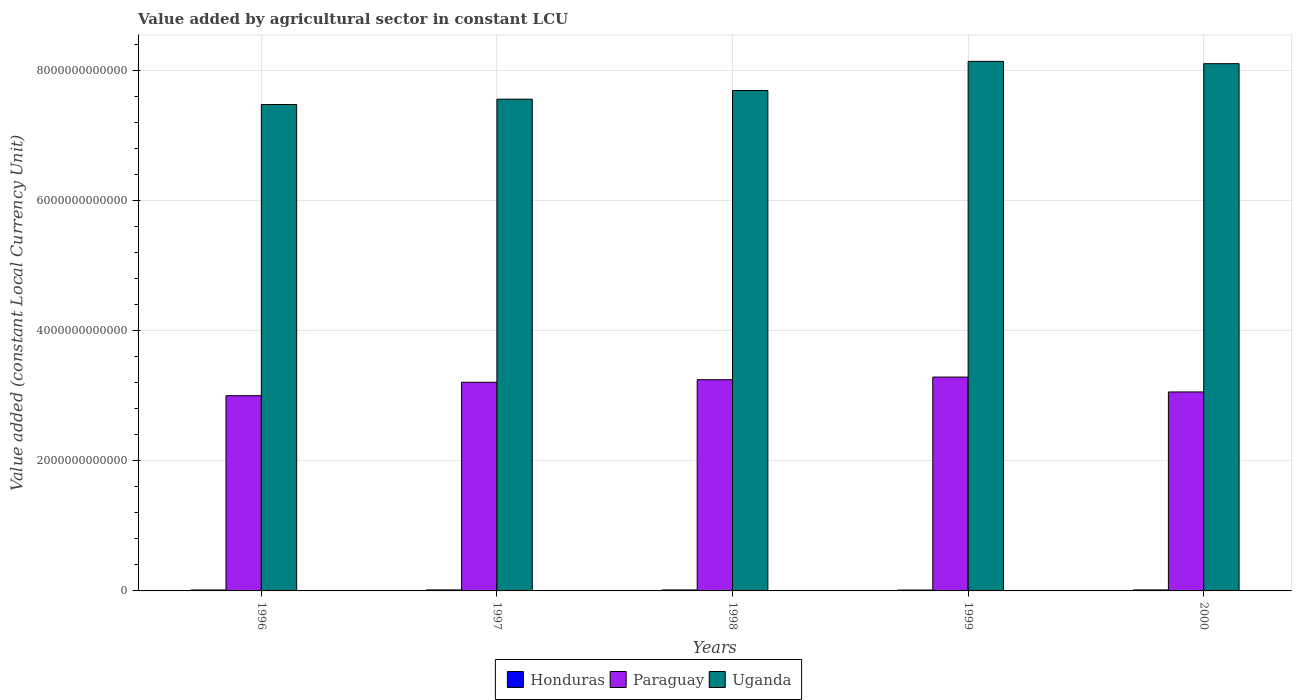How many groups of bars are there?
Ensure brevity in your answer.  5. Are the number of bars per tick equal to the number of legend labels?
Your answer should be compact. Yes. Are the number of bars on each tick of the X-axis equal?
Provide a succinct answer. Yes. How many bars are there on the 4th tick from the left?
Give a very brief answer. 3. How many bars are there on the 3rd tick from the right?
Ensure brevity in your answer.  3. What is the label of the 3rd group of bars from the left?
Your answer should be very brief. 1998. In how many cases, is the number of bars for a given year not equal to the number of legend labels?
Provide a short and direct response. 0. What is the value added by agricultural sector in Paraguay in 1998?
Your answer should be compact. 3.25e+12. Across all years, what is the maximum value added by agricultural sector in Paraguay?
Provide a succinct answer. 3.29e+12. Across all years, what is the minimum value added by agricultural sector in Uganda?
Give a very brief answer. 7.48e+12. What is the total value added by agricultural sector in Uganda in the graph?
Your answer should be very brief. 3.90e+13. What is the difference between the value added by agricultural sector in Paraguay in 1997 and that in 2000?
Your answer should be very brief. 1.49e+11. What is the difference between the value added by agricultural sector in Honduras in 1998 and the value added by agricultural sector in Uganda in 1996?
Give a very brief answer. -7.47e+12. What is the average value added by agricultural sector in Paraguay per year?
Offer a terse response. 3.16e+12. In the year 1997, what is the difference between the value added by agricultural sector in Paraguay and value added by agricultural sector in Honduras?
Provide a succinct answer. 3.19e+12. In how many years, is the value added by agricultural sector in Paraguay greater than 4000000000000 LCU?
Give a very brief answer. 0. What is the ratio of the value added by agricultural sector in Uganda in 1996 to that in 2000?
Ensure brevity in your answer.  0.92. What is the difference between the highest and the second highest value added by agricultural sector in Honduras?
Provide a succinct answer. 4.65e+07. What is the difference between the highest and the lowest value added by agricultural sector in Paraguay?
Give a very brief answer. 2.86e+11. In how many years, is the value added by agricultural sector in Uganda greater than the average value added by agricultural sector in Uganda taken over all years?
Your answer should be compact. 2. What does the 3rd bar from the left in 1999 represents?
Provide a short and direct response. Uganda. What does the 2nd bar from the right in 1998 represents?
Make the answer very short. Paraguay. Is it the case that in every year, the sum of the value added by agricultural sector in Honduras and value added by agricultural sector in Paraguay is greater than the value added by agricultural sector in Uganda?
Your answer should be compact. No. How many bars are there?
Provide a succinct answer. 15. Are all the bars in the graph horizontal?
Offer a very short reply. No. How many years are there in the graph?
Ensure brevity in your answer.  5. What is the difference between two consecutive major ticks on the Y-axis?
Ensure brevity in your answer.  2.00e+12. How many legend labels are there?
Provide a succinct answer. 3. What is the title of the graph?
Give a very brief answer. Value added by agricultural sector in constant LCU. What is the label or title of the X-axis?
Provide a short and direct response. Years. What is the label or title of the Y-axis?
Your answer should be compact. Value added (constant Local Currency Unit). What is the Value added (constant Local Currency Unit) in Honduras in 1996?
Offer a terse response. 1.47e+1. What is the Value added (constant Local Currency Unit) of Paraguay in 1996?
Ensure brevity in your answer.  3.00e+12. What is the Value added (constant Local Currency Unit) in Uganda in 1996?
Keep it short and to the point. 7.48e+12. What is the Value added (constant Local Currency Unit) of Honduras in 1997?
Your response must be concise. 1.53e+1. What is the Value added (constant Local Currency Unit) in Paraguay in 1997?
Offer a terse response. 3.21e+12. What is the Value added (constant Local Currency Unit) of Uganda in 1997?
Provide a short and direct response. 7.57e+12. What is the Value added (constant Local Currency Unit) in Honduras in 1998?
Offer a very short reply. 1.50e+1. What is the Value added (constant Local Currency Unit) of Paraguay in 1998?
Offer a terse response. 3.25e+12. What is the Value added (constant Local Currency Unit) of Uganda in 1998?
Offer a terse response. 7.70e+12. What is the Value added (constant Local Currency Unit) of Honduras in 1999?
Keep it short and to the point. 1.37e+1. What is the Value added (constant Local Currency Unit) in Paraguay in 1999?
Keep it short and to the point. 3.29e+12. What is the Value added (constant Local Currency Unit) of Uganda in 1999?
Provide a short and direct response. 8.15e+12. What is the Value added (constant Local Currency Unit) of Honduras in 2000?
Your response must be concise. 1.53e+1. What is the Value added (constant Local Currency Unit) of Paraguay in 2000?
Your answer should be compact. 3.06e+12. What is the Value added (constant Local Currency Unit) of Uganda in 2000?
Your answer should be very brief. 8.11e+12. Across all years, what is the maximum Value added (constant Local Currency Unit) in Honduras?
Ensure brevity in your answer.  1.53e+1. Across all years, what is the maximum Value added (constant Local Currency Unit) of Paraguay?
Provide a succinct answer. 3.29e+12. Across all years, what is the maximum Value added (constant Local Currency Unit) in Uganda?
Make the answer very short. 8.15e+12. Across all years, what is the minimum Value added (constant Local Currency Unit) of Honduras?
Provide a short and direct response. 1.37e+1. Across all years, what is the minimum Value added (constant Local Currency Unit) in Paraguay?
Give a very brief answer. 3.00e+12. Across all years, what is the minimum Value added (constant Local Currency Unit) in Uganda?
Provide a succinct answer. 7.48e+12. What is the total Value added (constant Local Currency Unit) in Honduras in the graph?
Offer a very short reply. 7.40e+1. What is the total Value added (constant Local Currency Unit) in Paraguay in the graph?
Keep it short and to the point. 1.58e+13. What is the total Value added (constant Local Currency Unit) of Uganda in the graph?
Give a very brief answer. 3.90e+13. What is the difference between the Value added (constant Local Currency Unit) in Honduras in 1996 and that in 1997?
Your response must be concise. -6.22e+08. What is the difference between the Value added (constant Local Currency Unit) of Paraguay in 1996 and that in 1997?
Give a very brief answer. -2.06e+11. What is the difference between the Value added (constant Local Currency Unit) in Uganda in 1996 and that in 1997?
Keep it short and to the point. -8.15e+1. What is the difference between the Value added (constant Local Currency Unit) in Honduras in 1996 and that in 1998?
Provide a succinct answer. -3.34e+08. What is the difference between the Value added (constant Local Currency Unit) of Paraguay in 1996 and that in 1998?
Your answer should be compact. -2.46e+11. What is the difference between the Value added (constant Local Currency Unit) in Uganda in 1996 and that in 1998?
Your answer should be very brief. -2.15e+11. What is the difference between the Value added (constant Local Currency Unit) in Honduras in 1996 and that in 1999?
Your answer should be very brief. 9.38e+08. What is the difference between the Value added (constant Local Currency Unit) in Paraguay in 1996 and that in 1999?
Keep it short and to the point. -2.86e+11. What is the difference between the Value added (constant Local Currency Unit) in Uganda in 1996 and that in 1999?
Your answer should be very brief. -6.64e+11. What is the difference between the Value added (constant Local Currency Unit) in Honduras in 1996 and that in 2000?
Your answer should be compact. -6.69e+08. What is the difference between the Value added (constant Local Currency Unit) in Paraguay in 1996 and that in 2000?
Provide a succinct answer. -5.73e+1. What is the difference between the Value added (constant Local Currency Unit) of Uganda in 1996 and that in 2000?
Your answer should be compact. -6.28e+11. What is the difference between the Value added (constant Local Currency Unit) of Honduras in 1997 and that in 1998?
Offer a terse response. 2.88e+08. What is the difference between the Value added (constant Local Currency Unit) in Paraguay in 1997 and that in 1998?
Offer a very short reply. -3.94e+1. What is the difference between the Value added (constant Local Currency Unit) of Uganda in 1997 and that in 1998?
Offer a very short reply. -1.34e+11. What is the difference between the Value added (constant Local Currency Unit) in Honduras in 1997 and that in 1999?
Ensure brevity in your answer.  1.56e+09. What is the difference between the Value added (constant Local Currency Unit) of Paraguay in 1997 and that in 1999?
Give a very brief answer. -8.01e+1. What is the difference between the Value added (constant Local Currency Unit) of Uganda in 1997 and that in 1999?
Provide a short and direct response. -5.82e+11. What is the difference between the Value added (constant Local Currency Unit) in Honduras in 1997 and that in 2000?
Keep it short and to the point. -4.65e+07. What is the difference between the Value added (constant Local Currency Unit) in Paraguay in 1997 and that in 2000?
Provide a succinct answer. 1.49e+11. What is the difference between the Value added (constant Local Currency Unit) in Uganda in 1997 and that in 2000?
Your answer should be very brief. -5.46e+11. What is the difference between the Value added (constant Local Currency Unit) of Honduras in 1998 and that in 1999?
Your answer should be compact. 1.27e+09. What is the difference between the Value added (constant Local Currency Unit) in Paraguay in 1998 and that in 1999?
Keep it short and to the point. -4.06e+1. What is the difference between the Value added (constant Local Currency Unit) in Uganda in 1998 and that in 1999?
Provide a short and direct response. -4.48e+11. What is the difference between the Value added (constant Local Currency Unit) in Honduras in 1998 and that in 2000?
Your answer should be very brief. -3.34e+08. What is the difference between the Value added (constant Local Currency Unit) of Paraguay in 1998 and that in 2000?
Ensure brevity in your answer.  1.88e+11. What is the difference between the Value added (constant Local Currency Unit) in Uganda in 1998 and that in 2000?
Offer a very short reply. -4.13e+11. What is the difference between the Value added (constant Local Currency Unit) in Honduras in 1999 and that in 2000?
Your answer should be very brief. -1.61e+09. What is the difference between the Value added (constant Local Currency Unit) of Paraguay in 1999 and that in 2000?
Provide a short and direct response. 2.29e+11. What is the difference between the Value added (constant Local Currency Unit) in Uganda in 1999 and that in 2000?
Your answer should be very brief. 3.57e+1. What is the difference between the Value added (constant Local Currency Unit) in Honduras in 1996 and the Value added (constant Local Currency Unit) in Paraguay in 1997?
Your answer should be compact. -3.20e+12. What is the difference between the Value added (constant Local Currency Unit) in Honduras in 1996 and the Value added (constant Local Currency Unit) in Uganda in 1997?
Your response must be concise. -7.55e+12. What is the difference between the Value added (constant Local Currency Unit) of Paraguay in 1996 and the Value added (constant Local Currency Unit) of Uganda in 1997?
Your answer should be compact. -4.56e+12. What is the difference between the Value added (constant Local Currency Unit) of Honduras in 1996 and the Value added (constant Local Currency Unit) of Paraguay in 1998?
Your answer should be compact. -3.23e+12. What is the difference between the Value added (constant Local Currency Unit) of Honduras in 1996 and the Value added (constant Local Currency Unit) of Uganda in 1998?
Your answer should be very brief. -7.68e+12. What is the difference between the Value added (constant Local Currency Unit) of Paraguay in 1996 and the Value added (constant Local Currency Unit) of Uganda in 1998?
Your response must be concise. -4.70e+12. What is the difference between the Value added (constant Local Currency Unit) of Honduras in 1996 and the Value added (constant Local Currency Unit) of Paraguay in 1999?
Offer a very short reply. -3.28e+12. What is the difference between the Value added (constant Local Currency Unit) of Honduras in 1996 and the Value added (constant Local Currency Unit) of Uganda in 1999?
Your answer should be very brief. -8.13e+12. What is the difference between the Value added (constant Local Currency Unit) in Paraguay in 1996 and the Value added (constant Local Currency Unit) in Uganda in 1999?
Your response must be concise. -5.14e+12. What is the difference between the Value added (constant Local Currency Unit) in Honduras in 1996 and the Value added (constant Local Currency Unit) in Paraguay in 2000?
Ensure brevity in your answer.  -3.05e+12. What is the difference between the Value added (constant Local Currency Unit) in Honduras in 1996 and the Value added (constant Local Currency Unit) in Uganda in 2000?
Offer a terse response. -8.10e+12. What is the difference between the Value added (constant Local Currency Unit) of Paraguay in 1996 and the Value added (constant Local Currency Unit) of Uganda in 2000?
Give a very brief answer. -5.11e+12. What is the difference between the Value added (constant Local Currency Unit) of Honduras in 1997 and the Value added (constant Local Currency Unit) of Paraguay in 1998?
Your response must be concise. -3.23e+12. What is the difference between the Value added (constant Local Currency Unit) of Honduras in 1997 and the Value added (constant Local Currency Unit) of Uganda in 1998?
Your answer should be very brief. -7.68e+12. What is the difference between the Value added (constant Local Currency Unit) of Paraguay in 1997 and the Value added (constant Local Currency Unit) of Uganda in 1998?
Offer a very short reply. -4.49e+12. What is the difference between the Value added (constant Local Currency Unit) in Honduras in 1997 and the Value added (constant Local Currency Unit) in Paraguay in 1999?
Make the answer very short. -3.27e+12. What is the difference between the Value added (constant Local Currency Unit) of Honduras in 1997 and the Value added (constant Local Currency Unit) of Uganda in 1999?
Provide a succinct answer. -8.13e+12. What is the difference between the Value added (constant Local Currency Unit) in Paraguay in 1997 and the Value added (constant Local Currency Unit) in Uganda in 1999?
Keep it short and to the point. -4.94e+12. What is the difference between the Value added (constant Local Currency Unit) in Honduras in 1997 and the Value added (constant Local Currency Unit) in Paraguay in 2000?
Keep it short and to the point. -3.05e+12. What is the difference between the Value added (constant Local Currency Unit) of Honduras in 1997 and the Value added (constant Local Currency Unit) of Uganda in 2000?
Provide a short and direct response. -8.10e+12. What is the difference between the Value added (constant Local Currency Unit) of Paraguay in 1997 and the Value added (constant Local Currency Unit) of Uganda in 2000?
Ensure brevity in your answer.  -4.90e+12. What is the difference between the Value added (constant Local Currency Unit) in Honduras in 1998 and the Value added (constant Local Currency Unit) in Paraguay in 1999?
Your answer should be very brief. -3.28e+12. What is the difference between the Value added (constant Local Currency Unit) in Honduras in 1998 and the Value added (constant Local Currency Unit) in Uganda in 1999?
Give a very brief answer. -8.13e+12. What is the difference between the Value added (constant Local Currency Unit) in Paraguay in 1998 and the Value added (constant Local Currency Unit) in Uganda in 1999?
Make the answer very short. -4.90e+12. What is the difference between the Value added (constant Local Currency Unit) of Honduras in 1998 and the Value added (constant Local Currency Unit) of Paraguay in 2000?
Your answer should be compact. -3.05e+12. What is the difference between the Value added (constant Local Currency Unit) in Honduras in 1998 and the Value added (constant Local Currency Unit) in Uganda in 2000?
Offer a terse response. -8.10e+12. What is the difference between the Value added (constant Local Currency Unit) of Paraguay in 1998 and the Value added (constant Local Currency Unit) of Uganda in 2000?
Your answer should be compact. -4.86e+12. What is the difference between the Value added (constant Local Currency Unit) in Honduras in 1999 and the Value added (constant Local Currency Unit) in Paraguay in 2000?
Give a very brief answer. -3.05e+12. What is the difference between the Value added (constant Local Currency Unit) in Honduras in 1999 and the Value added (constant Local Currency Unit) in Uganda in 2000?
Offer a very short reply. -8.10e+12. What is the difference between the Value added (constant Local Currency Unit) of Paraguay in 1999 and the Value added (constant Local Currency Unit) of Uganda in 2000?
Give a very brief answer. -4.82e+12. What is the average Value added (constant Local Currency Unit) in Honduras per year?
Your answer should be very brief. 1.48e+1. What is the average Value added (constant Local Currency Unit) in Paraguay per year?
Keep it short and to the point. 3.16e+12. What is the average Value added (constant Local Currency Unit) in Uganda per year?
Ensure brevity in your answer.  7.80e+12. In the year 1996, what is the difference between the Value added (constant Local Currency Unit) in Honduras and Value added (constant Local Currency Unit) in Paraguay?
Provide a short and direct response. -2.99e+12. In the year 1996, what is the difference between the Value added (constant Local Currency Unit) of Honduras and Value added (constant Local Currency Unit) of Uganda?
Provide a short and direct response. -7.47e+12. In the year 1996, what is the difference between the Value added (constant Local Currency Unit) in Paraguay and Value added (constant Local Currency Unit) in Uganda?
Your answer should be compact. -4.48e+12. In the year 1997, what is the difference between the Value added (constant Local Currency Unit) of Honduras and Value added (constant Local Currency Unit) of Paraguay?
Your response must be concise. -3.19e+12. In the year 1997, what is the difference between the Value added (constant Local Currency Unit) in Honduras and Value added (constant Local Currency Unit) in Uganda?
Give a very brief answer. -7.55e+12. In the year 1997, what is the difference between the Value added (constant Local Currency Unit) of Paraguay and Value added (constant Local Currency Unit) of Uganda?
Provide a succinct answer. -4.36e+12. In the year 1998, what is the difference between the Value added (constant Local Currency Unit) in Honduras and Value added (constant Local Currency Unit) in Paraguay?
Your answer should be very brief. -3.23e+12. In the year 1998, what is the difference between the Value added (constant Local Currency Unit) in Honduras and Value added (constant Local Currency Unit) in Uganda?
Make the answer very short. -7.68e+12. In the year 1998, what is the difference between the Value added (constant Local Currency Unit) in Paraguay and Value added (constant Local Currency Unit) in Uganda?
Give a very brief answer. -4.45e+12. In the year 1999, what is the difference between the Value added (constant Local Currency Unit) of Honduras and Value added (constant Local Currency Unit) of Paraguay?
Give a very brief answer. -3.28e+12. In the year 1999, what is the difference between the Value added (constant Local Currency Unit) in Honduras and Value added (constant Local Currency Unit) in Uganda?
Provide a short and direct response. -8.13e+12. In the year 1999, what is the difference between the Value added (constant Local Currency Unit) in Paraguay and Value added (constant Local Currency Unit) in Uganda?
Ensure brevity in your answer.  -4.86e+12. In the year 2000, what is the difference between the Value added (constant Local Currency Unit) of Honduras and Value added (constant Local Currency Unit) of Paraguay?
Your answer should be compact. -3.05e+12. In the year 2000, what is the difference between the Value added (constant Local Currency Unit) of Honduras and Value added (constant Local Currency Unit) of Uganda?
Keep it short and to the point. -8.10e+12. In the year 2000, what is the difference between the Value added (constant Local Currency Unit) of Paraguay and Value added (constant Local Currency Unit) of Uganda?
Provide a short and direct response. -5.05e+12. What is the ratio of the Value added (constant Local Currency Unit) in Honduras in 1996 to that in 1997?
Offer a very short reply. 0.96. What is the ratio of the Value added (constant Local Currency Unit) in Paraguay in 1996 to that in 1997?
Your response must be concise. 0.94. What is the ratio of the Value added (constant Local Currency Unit) in Honduras in 1996 to that in 1998?
Provide a succinct answer. 0.98. What is the ratio of the Value added (constant Local Currency Unit) in Paraguay in 1996 to that in 1998?
Offer a terse response. 0.92. What is the ratio of the Value added (constant Local Currency Unit) in Uganda in 1996 to that in 1998?
Ensure brevity in your answer.  0.97. What is the ratio of the Value added (constant Local Currency Unit) of Honduras in 1996 to that in 1999?
Make the answer very short. 1.07. What is the ratio of the Value added (constant Local Currency Unit) in Uganda in 1996 to that in 1999?
Keep it short and to the point. 0.92. What is the ratio of the Value added (constant Local Currency Unit) of Honduras in 1996 to that in 2000?
Offer a very short reply. 0.96. What is the ratio of the Value added (constant Local Currency Unit) in Paraguay in 1996 to that in 2000?
Make the answer very short. 0.98. What is the ratio of the Value added (constant Local Currency Unit) of Uganda in 1996 to that in 2000?
Ensure brevity in your answer.  0.92. What is the ratio of the Value added (constant Local Currency Unit) in Honduras in 1997 to that in 1998?
Provide a succinct answer. 1.02. What is the ratio of the Value added (constant Local Currency Unit) in Paraguay in 1997 to that in 1998?
Ensure brevity in your answer.  0.99. What is the ratio of the Value added (constant Local Currency Unit) in Uganda in 1997 to that in 1998?
Your answer should be compact. 0.98. What is the ratio of the Value added (constant Local Currency Unit) of Honduras in 1997 to that in 1999?
Your answer should be compact. 1.11. What is the ratio of the Value added (constant Local Currency Unit) of Paraguay in 1997 to that in 1999?
Give a very brief answer. 0.98. What is the ratio of the Value added (constant Local Currency Unit) in Uganda in 1997 to that in 1999?
Provide a succinct answer. 0.93. What is the ratio of the Value added (constant Local Currency Unit) of Paraguay in 1997 to that in 2000?
Provide a short and direct response. 1.05. What is the ratio of the Value added (constant Local Currency Unit) in Uganda in 1997 to that in 2000?
Your answer should be very brief. 0.93. What is the ratio of the Value added (constant Local Currency Unit) in Honduras in 1998 to that in 1999?
Keep it short and to the point. 1.09. What is the ratio of the Value added (constant Local Currency Unit) of Uganda in 1998 to that in 1999?
Offer a terse response. 0.94. What is the ratio of the Value added (constant Local Currency Unit) of Honduras in 1998 to that in 2000?
Provide a short and direct response. 0.98. What is the ratio of the Value added (constant Local Currency Unit) in Paraguay in 1998 to that in 2000?
Offer a terse response. 1.06. What is the ratio of the Value added (constant Local Currency Unit) of Uganda in 1998 to that in 2000?
Ensure brevity in your answer.  0.95. What is the ratio of the Value added (constant Local Currency Unit) in Honduras in 1999 to that in 2000?
Provide a short and direct response. 0.9. What is the ratio of the Value added (constant Local Currency Unit) in Paraguay in 1999 to that in 2000?
Offer a terse response. 1.07. What is the difference between the highest and the second highest Value added (constant Local Currency Unit) in Honduras?
Offer a terse response. 4.65e+07. What is the difference between the highest and the second highest Value added (constant Local Currency Unit) in Paraguay?
Offer a terse response. 4.06e+1. What is the difference between the highest and the second highest Value added (constant Local Currency Unit) in Uganda?
Give a very brief answer. 3.57e+1. What is the difference between the highest and the lowest Value added (constant Local Currency Unit) of Honduras?
Your response must be concise. 1.61e+09. What is the difference between the highest and the lowest Value added (constant Local Currency Unit) of Paraguay?
Your answer should be very brief. 2.86e+11. What is the difference between the highest and the lowest Value added (constant Local Currency Unit) in Uganda?
Keep it short and to the point. 6.64e+11. 